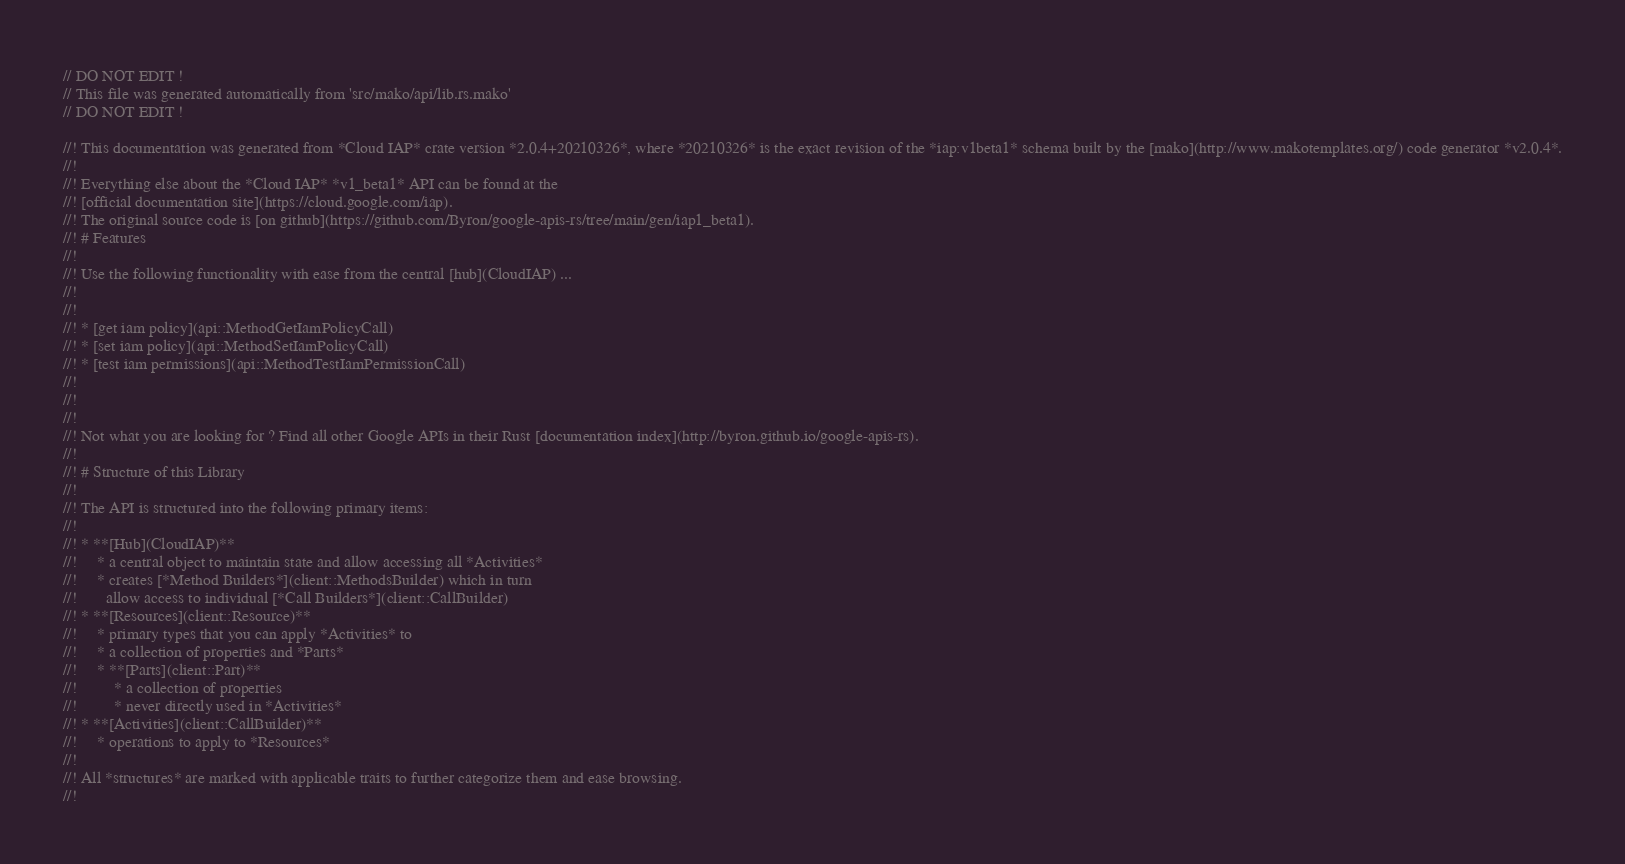Convert code to text. <code><loc_0><loc_0><loc_500><loc_500><_Rust_>// DO NOT EDIT !
// This file was generated automatically from 'src/mako/api/lib.rs.mako'
// DO NOT EDIT !

//! This documentation was generated from *Cloud IAP* crate version *2.0.4+20210326*, where *20210326* is the exact revision of the *iap:v1beta1* schema built by the [mako](http://www.makotemplates.org/) code generator *v2.0.4*.
//! 
//! Everything else about the *Cloud IAP* *v1_beta1* API can be found at the
//! [official documentation site](https://cloud.google.com/iap).
//! The original source code is [on github](https://github.com/Byron/google-apis-rs/tree/main/gen/iap1_beta1).
//! # Features
//! 
//! Use the following functionality with ease from the central [hub](CloudIAP) ... 
//! 
//! 
//! * [get iam policy](api::MethodGetIamPolicyCall)
//! * [set iam policy](api::MethodSetIamPolicyCall)
//! * [test iam permissions](api::MethodTestIamPermissionCall)
//! 
//! 
//! 
//! Not what you are looking for ? Find all other Google APIs in their Rust [documentation index](http://byron.github.io/google-apis-rs).
//! 
//! # Structure of this Library
//! 
//! The API is structured into the following primary items:
//! 
//! * **[Hub](CloudIAP)**
//!     * a central object to maintain state and allow accessing all *Activities*
//!     * creates [*Method Builders*](client::MethodsBuilder) which in turn
//!       allow access to individual [*Call Builders*](client::CallBuilder)
//! * **[Resources](client::Resource)**
//!     * primary types that you can apply *Activities* to
//!     * a collection of properties and *Parts*
//!     * **[Parts](client::Part)**
//!         * a collection of properties
//!         * never directly used in *Activities*
//! * **[Activities](client::CallBuilder)**
//!     * operations to apply to *Resources*
//! 
//! All *structures* are marked with applicable traits to further categorize them and ease browsing.
//! </code> 